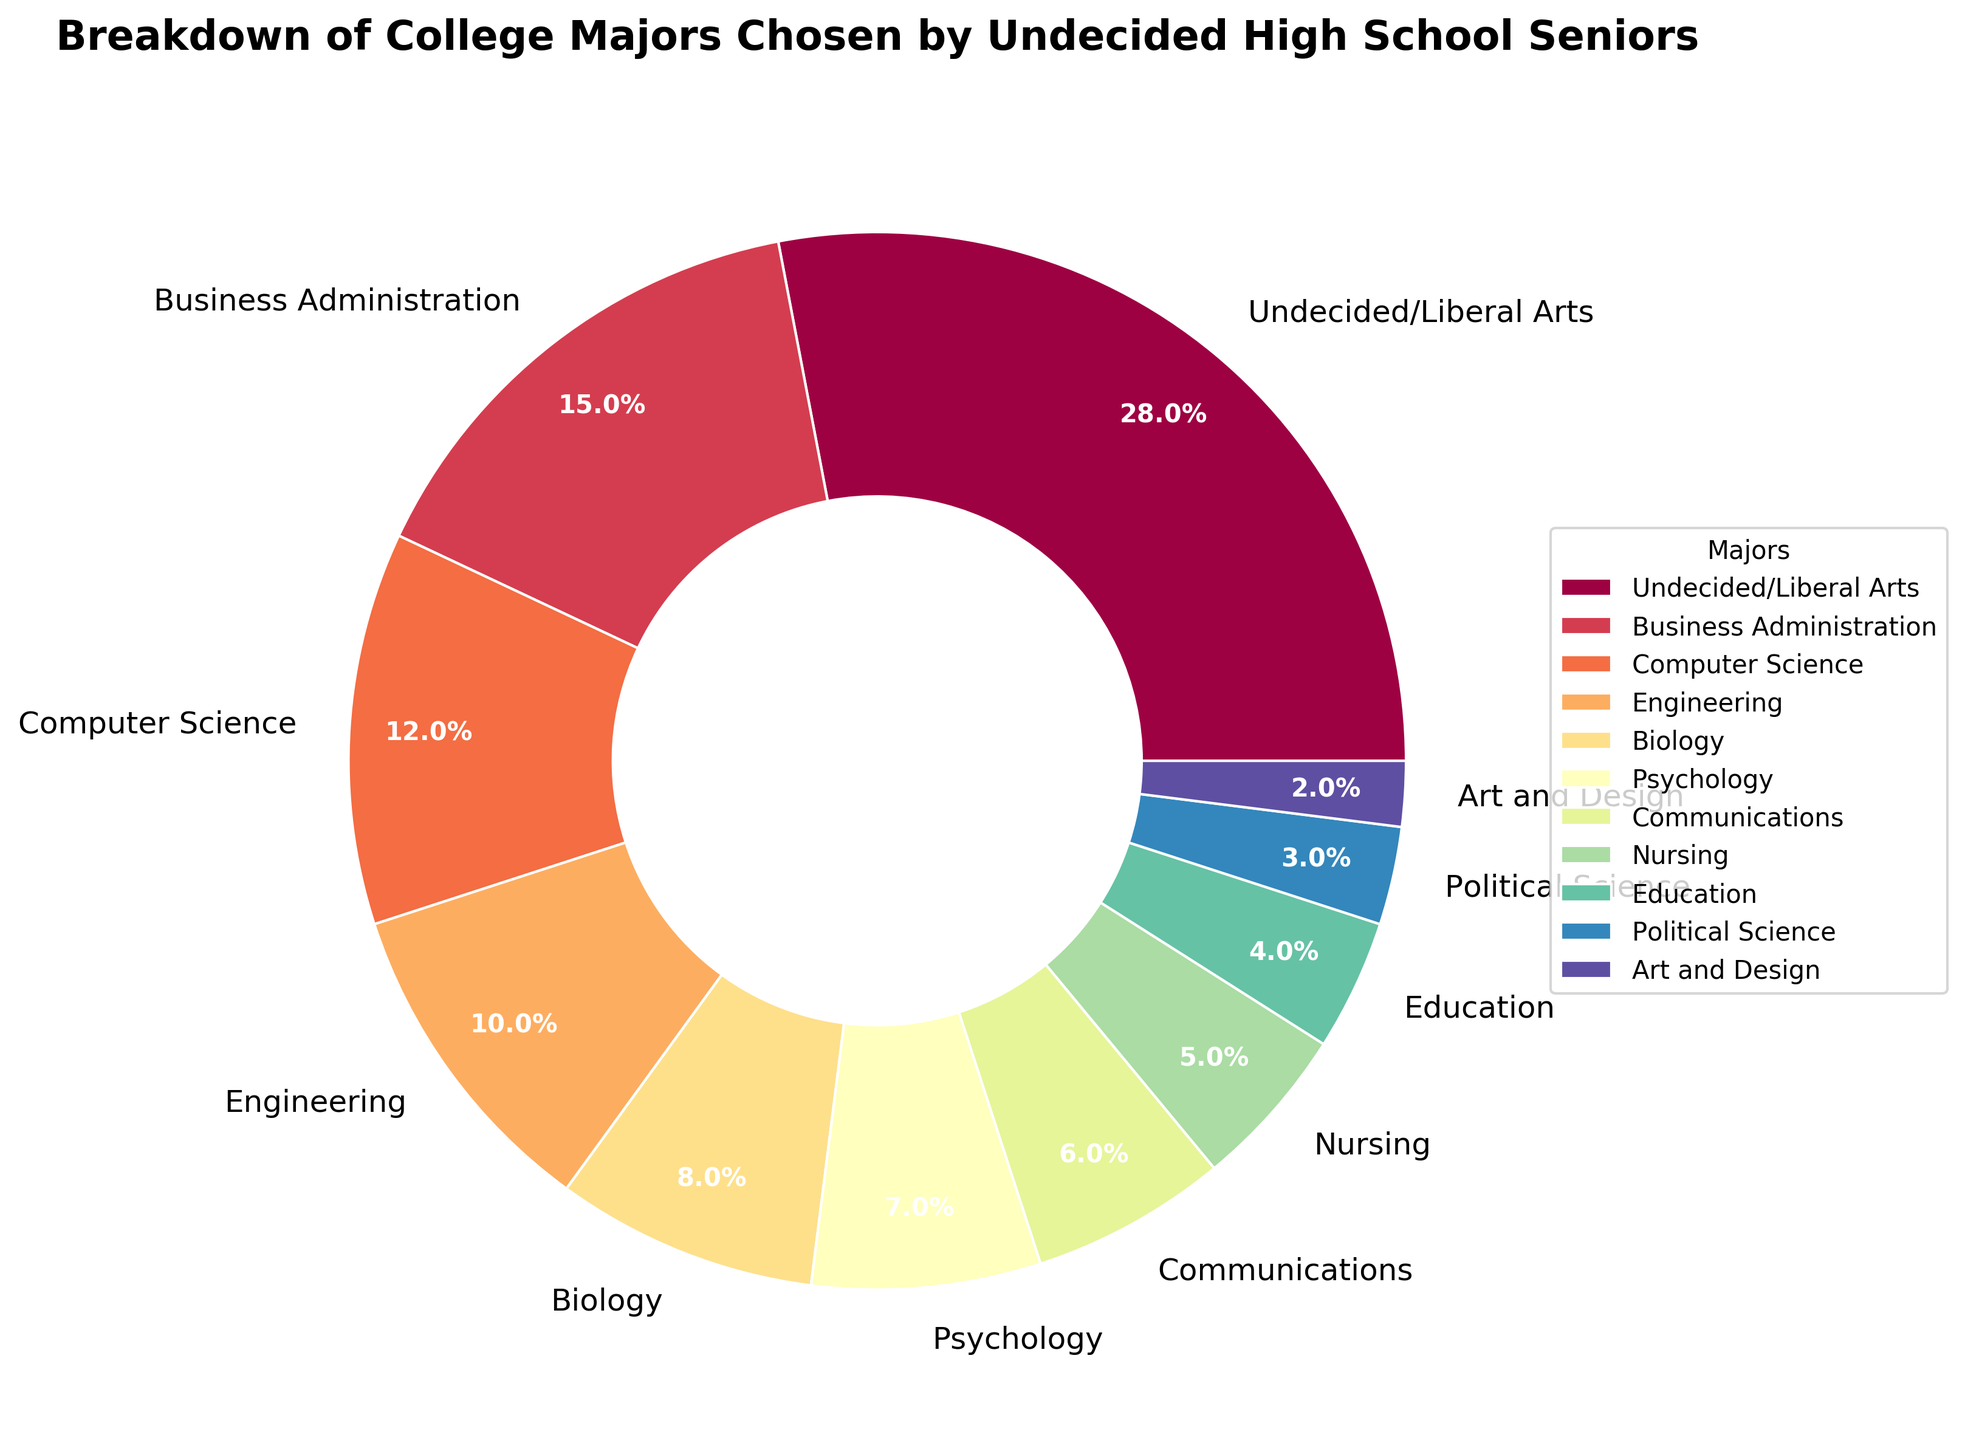How many different majors are represented in the pie chart? Count the number of unique labels in the pie chart. There are 11 different labels, each for a unique major.
Answer: 11 Which major has the second highest percentage? Observe the percentages next to each label. The second highest percentage is 15%, which corresponds to Business Administration.
Answer: Business Administration What is the total percentage of students who are still undecided or chose Liberal Arts and those who chose Business Administration? Add the percentage for Undecided/Liberal Arts (28%) and Business Administration (15%). 28% + 15% = 43%.
Answer: 43% Are there more students choosing Engineering or Nursing? Compare the percentages for Engineering (10%) and Nursing (5%). 10% is greater than 5%, so more students are choosing Engineering.
Answer: Engineering Which major has the smallest percentage of students? Identify the label with the smallest percentage. The smallest percentage is 2%, corresponding to Art and Design.
Answer: Art and Design What is the percentage difference between students choosing Psychology and those choosing Biology? Subtract the percentage of Psychology (7%) from Biology (8%). 8% - 7% = 1%.
Answer: 1% What percentage of students chose Communications, Nursing, and Education combined? Add the percentages for Communications (6%), Nursing (5%), and Education (4%). 6% + 5% + 4% = 15%.
Answer: 15% Which major has a higher percentage, Political Science or Communications? Compare the percentages for Political Science (3%) and Communications (6%). 6% is greater than 3%, so Communications has a higher percentage.
Answer: Communications What is the average percentage of students choosing Engineering, Computer Science, and Biology? Add the percentages for Engineering (10%), Computer Science (12%), and Biology (8%), then divide by 3. (10% + 12% + 8%) / 3 = 10%.
Answer: 10% What is the combined percentage of students choosing majors outside of STEM (Science, Technology, Engineering, Mathematics) fields? Sum the percentages of majors that are not STEM: Undecided/Liberal Arts (28%), Business Administration (15%), Psychology (7%), Communications (6%), Nursing (5%), Education (4%), Political Science (3%), Art and Design (2%). 28% + 15% + 7% + 6% + 5% + 4% + 3% + 2% = 70%.
Answer: 70% 